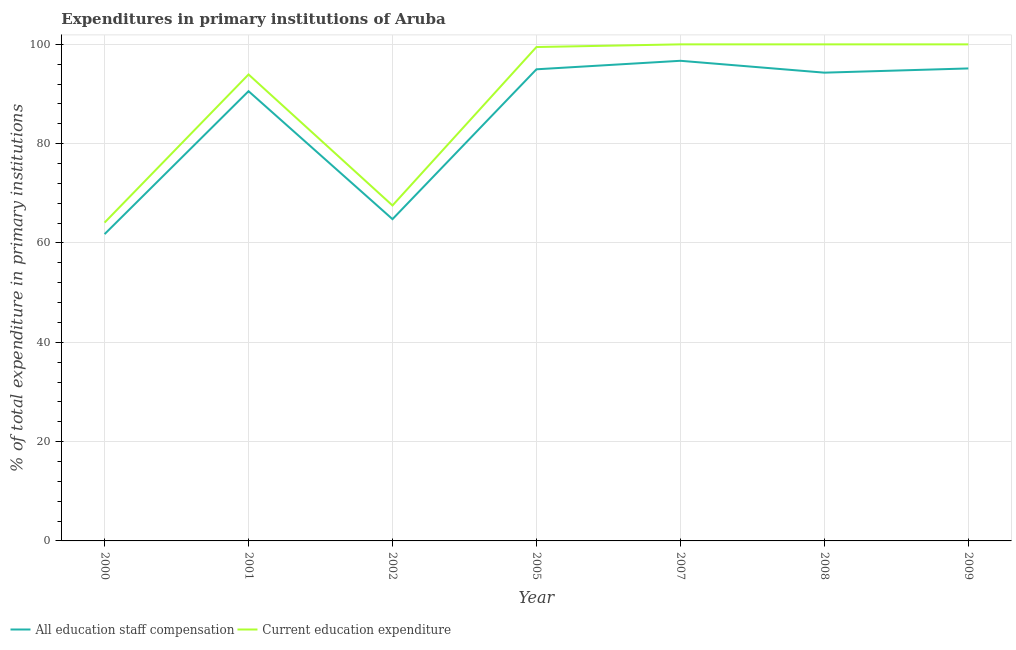How many different coloured lines are there?
Ensure brevity in your answer.  2. Does the line corresponding to expenditure in staff compensation intersect with the line corresponding to expenditure in education?
Your response must be concise. No. Is the number of lines equal to the number of legend labels?
Your response must be concise. Yes. What is the expenditure in education in 2009?
Offer a very short reply. 100. Across all years, what is the maximum expenditure in staff compensation?
Provide a succinct answer. 96.69. Across all years, what is the minimum expenditure in education?
Your answer should be very brief. 64.11. In which year was the expenditure in staff compensation maximum?
Your response must be concise. 2007. In which year was the expenditure in staff compensation minimum?
Give a very brief answer. 2000. What is the total expenditure in staff compensation in the graph?
Provide a short and direct response. 598.28. What is the difference between the expenditure in education in 2001 and that in 2005?
Your answer should be very brief. -5.52. What is the difference between the expenditure in education in 2002 and the expenditure in staff compensation in 2009?
Make the answer very short. -27.6. What is the average expenditure in education per year?
Ensure brevity in your answer.  89.29. In the year 2005, what is the difference between the expenditure in staff compensation and expenditure in education?
Give a very brief answer. -4.48. What is the ratio of the expenditure in education in 2000 to that in 2009?
Offer a very short reply. 0.64. Is the difference between the expenditure in education in 2007 and 2008 greater than the difference between the expenditure in staff compensation in 2007 and 2008?
Offer a very short reply. No. What is the difference between the highest and the lowest expenditure in education?
Offer a terse response. 35.89. In how many years, is the expenditure in staff compensation greater than the average expenditure in staff compensation taken over all years?
Offer a very short reply. 5. Is the expenditure in staff compensation strictly greater than the expenditure in education over the years?
Offer a terse response. No. Is the expenditure in education strictly less than the expenditure in staff compensation over the years?
Offer a very short reply. No. Are the values on the major ticks of Y-axis written in scientific E-notation?
Offer a terse response. No. Does the graph contain any zero values?
Offer a very short reply. No. Does the graph contain grids?
Provide a short and direct response. Yes. How are the legend labels stacked?
Your response must be concise. Horizontal. What is the title of the graph?
Your response must be concise. Expenditures in primary institutions of Aruba. What is the label or title of the Y-axis?
Your response must be concise. % of total expenditure in primary institutions. What is the % of total expenditure in primary institutions in All education staff compensation in 2000?
Keep it short and to the point. 61.78. What is the % of total expenditure in primary institutions of Current education expenditure in 2000?
Provide a short and direct response. 64.11. What is the % of total expenditure in primary institutions in All education staff compensation in 2001?
Your answer should be very brief. 90.57. What is the % of total expenditure in primary institutions in Current education expenditure in 2001?
Offer a very short reply. 93.94. What is the % of total expenditure in primary institutions in All education staff compensation in 2002?
Provide a short and direct response. 64.8. What is the % of total expenditure in primary institutions in Current education expenditure in 2002?
Your answer should be compact. 67.55. What is the % of total expenditure in primary institutions in All education staff compensation in 2005?
Make the answer very short. 94.98. What is the % of total expenditure in primary institutions of Current education expenditure in 2005?
Ensure brevity in your answer.  99.46. What is the % of total expenditure in primary institutions in All education staff compensation in 2007?
Your answer should be very brief. 96.69. What is the % of total expenditure in primary institutions in Current education expenditure in 2007?
Provide a short and direct response. 100. What is the % of total expenditure in primary institutions in All education staff compensation in 2008?
Keep it short and to the point. 94.3. What is the % of total expenditure in primary institutions of Current education expenditure in 2008?
Ensure brevity in your answer.  100. What is the % of total expenditure in primary institutions of All education staff compensation in 2009?
Your response must be concise. 95.15. What is the % of total expenditure in primary institutions of Current education expenditure in 2009?
Give a very brief answer. 100. Across all years, what is the maximum % of total expenditure in primary institutions of All education staff compensation?
Ensure brevity in your answer.  96.69. Across all years, what is the maximum % of total expenditure in primary institutions in Current education expenditure?
Make the answer very short. 100. Across all years, what is the minimum % of total expenditure in primary institutions in All education staff compensation?
Provide a short and direct response. 61.78. Across all years, what is the minimum % of total expenditure in primary institutions in Current education expenditure?
Ensure brevity in your answer.  64.11. What is the total % of total expenditure in primary institutions in All education staff compensation in the graph?
Provide a succinct answer. 598.28. What is the total % of total expenditure in primary institutions of Current education expenditure in the graph?
Give a very brief answer. 625.06. What is the difference between the % of total expenditure in primary institutions in All education staff compensation in 2000 and that in 2001?
Offer a very short reply. -28.79. What is the difference between the % of total expenditure in primary institutions in Current education expenditure in 2000 and that in 2001?
Ensure brevity in your answer.  -29.83. What is the difference between the % of total expenditure in primary institutions in All education staff compensation in 2000 and that in 2002?
Your response must be concise. -3.02. What is the difference between the % of total expenditure in primary institutions of Current education expenditure in 2000 and that in 2002?
Your answer should be compact. -3.44. What is the difference between the % of total expenditure in primary institutions of All education staff compensation in 2000 and that in 2005?
Your answer should be compact. -33.2. What is the difference between the % of total expenditure in primary institutions of Current education expenditure in 2000 and that in 2005?
Provide a succinct answer. -35.35. What is the difference between the % of total expenditure in primary institutions of All education staff compensation in 2000 and that in 2007?
Your response must be concise. -34.91. What is the difference between the % of total expenditure in primary institutions of Current education expenditure in 2000 and that in 2007?
Provide a succinct answer. -35.89. What is the difference between the % of total expenditure in primary institutions of All education staff compensation in 2000 and that in 2008?
Offer a very short reply. -32.52. What is the difference between the % of total expenditure in primary institutions in Current education expenditure in 2000 and that in 2008?
Give a very brief answer. -35.89. What is the difference between the % of total expenditure in primary institutions of All education staff compensation in 2000 and that in 2009?
Offer a terse response. -33.37. What is the difference between the % of total expenditure in primary institutions of Current education expenditure in 2000 and that in 2009?
Provide a succinct answer. -35.89. What is the difference between the % of total expenditure in primary institutions of All education staff compensation in 2001 and that in 2002?
Your answer should be very brief. 25.77. What is the difference between the % of total expenditure in primary institutions of Current education expenditure in 2001 and that in 2002?
Offer a very short reply. 26.38. What is the difference between the % of total expenditure in primary institutions in All education staff compensation in 2001 and that in 2005?
Offer a very short reply. -4.41. What is the difference between the % of total expenditure in primary institutions of Current education expenditure in 2001 and that in 2005?
Ensure brevity in your answer.  -5.52. What is the difference between the % of total expenditure in primary institutions in All education staff compensation in 2001 and that in 2007?
Offer a very short reply. -6.12. What is the difference between the % of total expenditure in primary institutions of Current education expenditure in 2001 and that in 2007?
Ensure brevity in your answer.  -6.06. What is the difference between the % of total expenditure in primary institutions of All education staff compensation in 2001 and that in 2008?
Provide a succinct answer. -3.73. What is the difference between the % of total expenditure in primary institutions in Current education expenditure in 2001 and that in 2008?
Your response must be concise. -6.06. What is the difference between the % of total expenditure in primary institutions in All education staff compensation in 2001 and that in 2009?
Your answer should be very brief. -4.58. What is the difference between the % of total expenditure in primary institutions of Current education expenditure in 2001 and that in 2009?
Make the answer very short. -6.06. What is the difference between the % of total expenditure in primary institutions of All education staff compensation in 2002 and that in 2005?
Make the answer very short. -30.18. What is the difference between the % of total expenditure in primary institutions in Current education expenditure in 2002 and that in 2005?
Keep it short and to the point. -31.91. What is the difference between the % of total expenditure in primary institutions of All education staff compensation in 2002 and that in 2007?
Make the answer very short. -31.89. What is the difference between the % of total expenditure in primary institutions of Current education expenditure in 2002 and that in 2007?
Your answer should be compact. -32.45. What is the difference between the % of total expenditure in primary institutions in All education staff compensation in 2002 and that in 2008?
Keep it short and to the point. -29.5. What is the difference between the % of total expenditure in primary institutions of Current education expenditure in 2002 and that in 2008?
Your answer should be compact. -32.45. What is the difference between the % of total expenditure in primary institutions of All education staff compensation in 2002 and that in 2009?
Give a very brief answer. -30.35. What is the difference between the % of total expenditure in primary institutions in Current education expenditure in 2002 and that in 2009?
Your answer should be compact. -32.45. What is the difference between the % of total expenditure in primary institutions of All education staff compensation in 2005 and that in 2007?
Keep it short and to the point. -1.71. What is the difference between the % of total expenditure in primary institutions in Current education expenditure in 2005 and that in 2007?
Ensure brevity in your answer.  -0.54. What is the difference between the % of total expenditure in primary institutions in All education staff compensation in 2005 and that in 2008?
Keep it short and to the point. 0.68. What is the difference between the % of total expenditure in primary institutions in Current education expenditure in 2005 and that in 2008?
Your response must be concise. -0.54. What is the difference between the % of total expenditure in primary institutions in All education staff compensation in 2005 and that in 2009?
Offer a terse response. -0.17. What is the difference between the % of total expenditure in primary institutions in Current education expenditure in 2005 and that in 2009?
Ensure brevity in your answer.  -0.54. What is the difference between the % of total expenditure in primary institutions in All education staff compensation in 2007 and that in 2008?
Your answer should be compact. 2.39. What is the difference between the % of total expenditure in primary institutions of All education staff compensation in 2007 and that in 2009?
Keep it short and to the point. 1.54. What is the difference between the % of total expenditure in primary institutions of Current education expenditure in 2007 and that in 2009?
Your answer should be very brief. 0. What is the difference between the % of total expenditure in primary institutions of All education staff compensation in 2008 and that in 2009?
Make the answer very short. -0.85. What is the difference between the % of total expenditure in primary institutions in Current education expenditure in 2008 and that in 2009?
Ensure brevity in your answer.  0. What is the difference between the % of total expenditure in primary institutions in All education staff compensation in 2000 and the % of total expenditure in primary institutions in Current education expenditure in 2001?
Provide a succinct answer. -32.15. What is the difference between the % of total expenditure in primary institutions in All education staff compensation in 2000 and the % of total expenditure in primary institutions in Current education expenditure in 2002?
Your answer should be very brief. -5.77. What is the difference between the % of total expenditure in primary institutions in All education staff compensation in 2000 and the % of total expenditure in primary institutions in Current education expenditure in 2005?
Ensure brevity in your answer.  -37.68. What is the difference between the % of total expenditure in primary institutions in All education staff compensation in 2000 and the % of total expenditure in primary institutions in Current education expenditure in 2007?
Offer a very short reply. -38.22. What is the difference between the % of total expenditure in primary institutions of All education staff compensation in 2000 and the % of total expenditure in primary institutions of Current education expenditure in 2008?
Your answer should be very brief. -38.22. What is the difference between the % of total expenditure in primary institutions of All education staff compensation in 2000 and the % of total expenditure in primary institutions of Current education expenditure in 2009?
Provide a short and direct response. -38.22. What is the difference between the % of total expenditure in primary institutions in All education staff compensation in 2001 and the % of total expenditure in primary institutions in Current education expenditure in 2002?
Your answer should be compact. 23.02. What is the difference between the % of total expenditure in primary institutions of All education staff compensation in 2001 and the % of total expenditure in primary institutions of Current education expenditure in 2005?
Make the answer very short. -8.89. What is the difference between the % of total expenditure in primary institutions in All education staff compensation in 2001 and the % of total expenditure in primary institutions in Current education expenditure in 2007?
Make the answer very short. -9.43. What is the difference between the % of total expenditure in primary institutions in All education staff compensation in 2001 and the % of total expenditure in primary institutions in Current education expenditure in 2008?
Your response must be concise. -9.43. What is the difference between the % of total expenditure in primary institutions of All education staff compensation in 2001 and the % of total expenditure in primary institutions of Current education expenditure in 2009?
Make the answer very short. -9.43. What is the difference between the % of total expenditure in primary institutions of All education staff compensation in 2002 and the % of total expenditure in primary institutions of Current education expenditure in 2005?
Provide a succinct answer. -34.66. What is the difference between the % of total expenditure in primary institutions of All education staff compensation in 2002 and the % of total expenditure in primary institutions of Current education expenditure in 2007?
Offer a very short reply. -35.2. What is the difference between the % of total expenditure in primary institutions in All education staff compensation in 2002 and the % of total expenditure in primary institutions in Current education expenditure in 2008?
Offer a very short reply. -35.2. What is the difference between the % of total expenditure in primary institutions of All education staff compensation in 2002 and the % of total expenditure in primary institutions of Current education expenditure in 2009?
Provide a short and direct response. -35.2. What is the difference between the % of total expenditure in primary institutions in All education staff compensation in 2005 and the % of total expenditure in primary institutions in Current education expenditure in 2007?
Your response must be concise. -5.02. What is the difference between the % of total expenditure in primary institutions of All education staff compensation in 2005 and the % of total expenditure in primary institutions of Current education expenditure in 2008?
Your answer should be very brief. -5.02. What is the difference between the % of total expenditure in primary institutions of All education staff compensation in 2005 and the % of total expenditure in primary institutions of Current education expenditure in 2009?
Your answer should be compact. -5.02. What is the difference between the % of total expenditure in primary institutions in All education staff compensation in 2007 and the % of total expenditure in primary institutions in Current education expenditure in 2008?
Ensure brevity in your answer.  -3.31. What is the difference between the % of total expenditure in primary institutions of All education staff compensation in 2007 and the % of total expenditure in primary institutions of Current education expenditure in 2009?
Your response must be concise. -3.31. What is the difference between the % of total expenditure in primary institutions of All education staff compensation in 2008 and the % of total expenditure in primary institutions of Current education expenditure in 2009?
Offer a terse response. -5.7. What is the average % of total expenditure in primary institutions in All education staff compensation per year?
Your answer should be very brief. 85.47. What is the average % of total expenditure in primary institutions in Current education expenditure per year?
Your answer should be compact. 89.29. In the year 2000, what is the difference between the % of total expenditure in primary institutions in All education staff compensation and % of total expenditure in primary institutions in Current education expenditure?
Offer a terse response. -2.33. In the year 2001, what is the difference between the % of total expenditure in primary institutions in All education staff compensation and % of total expenditure in primary institutions in Current education expenditure?
Your answer should be compact. -3.37. In the year 2002, what is the difference between the % of total expenditure in primary institutions of All education staff compensation and % of total expenditure in primary institutions of Current education expenditure?
Your answer should be very brief. -2.75. In the year 2005, what is the difference between the % of total expenditure in primary institutions of All education staff compensation and % of total expenditure in primary institutions of Current education expenditure?
Your answer should be very brief. -4.48. In the year 2007, what is the difference between the % of total expenditure in primary institutions of All education staff compensation and % of total expenditure in primary institutions of Current education expenditure?
Ensure brevity in your answer.  -3.31. In the year 2008, what is the difference between the % of total expenditure in primary institutions in All education staff compensation and % of total expenditure in primary institutions in Current education expenditure?
Keep it short and to the point. -5.7. In the year 2009, what is the difference between the % of total expenditure in primary institutions in All education staff compensation and % of total expenditure in primary institutions in Current education expenditure?
Your answer should be very brief. -4.85. What is the ratio of the % of total expenditure in primary institutions of All education staff compensation in 2000 to that in 2001?
Give a very brief answer. 0.68. What is the ratio of the % of total expenditure in primary institutions of Current education expenditure in 2000 to that in 2001?
Offer a terse response. 0.68. What is the ratio of the % of total expenditure in primary institutions in All education staff compensation in 2000 to that in 2002?
Your answer should be very brief. 0.95. What is the ratio of the % of total expenditure in primary institutions of Current education expenditure in 2000 to that in 2002?
Your response must be concise. 0.95. What is the ratio of the % of total expenditure in primary institutions of All education staff compensation in 2000 to that in 2005?
Make the answer very short. 0.65. What is the ratio of the % of total expenditure in primary institutions in Current education expenditure in 2000 to that in 2005?
Offer a terse response. 0.64. What is the ratio of the % of total expenditure in primary institutions in All education staff compensation in 2000 to that in 2007?
Offer a very short reply. 0.64. What is the ratio of the % of total expenditure in primary institutions of Current education expenditure in 2000 to that in 2007?
Provide a succinct answer. 0.64. What is the ratio of the % of total expenditure in primary institutions in All education staff compensation in 2000 to that in 2008?
Give a very brief answer. 0.66. What is the ratio of the % of total expenditure in primary institutions of Current education expenditure in 2000 to that in 2008?
Ensure brevity in your answer.  0.64. What is the ratio of the % of total expenditure in primary institutions in All education staff compensation in 2000 to that in 2009?
Offer a very short reply. 0.65. What is the ratio of the % of total expenditure in primary institutions in Current education expenditure in 2000 to that in 2009?
Ensure brevity in your answer.  0.64. What is the ratio of the % of total expenditure in primary institutions in All education staff compensation in 2001 to that in 2002?
Ensure brevity in your answer.  1.4. What is the ratio of the % of total expenditure in primary institutions in Current education expenditure in 2001 to that in 2002?
Keep it short and to the point. 1.39. What is the ratio of the % of total expenditure in primary institutions of All education staff compensation in 2001 to that in 2005?
Give a very brief answer. 0.95. What is the ratio of the % of total expenditure in primary institutions in Current education expenditure in 2001 to that in 2005?
Your answer should be very brief. 0.94. What is the ratio of the % of total expenditure in primary institutions in All education staff compensation in 2001 to that in 2007?
Provide a short and direct response. 0.94. What is the ratio of the % of total expenditure in primary institutions in Current education expenditure in 2001 to that in 2007?
Ensure brevity in your answer.  0.94. What is the ratio of the % of total expenditure in primary institutions of All education staff compensation in 2001 to that in 2008?
Your response must be concise. 0.96. What is the ratio of the % of total expenditure in primary institutions in Current education expenditure in 2001 to that in 2008?
Make the answer very short. 0.94. What is the ratio of the % of total expenditure in primary institutions of All education staff compensation in 2001 to that in 2009?
Make the answer very short. 0.95. What is the ratio of the % of total expenditure in primary institutions in Current education expenditure in 2001 to that in 2009?
Make the answer very short. 0.94. What is the ratio of the % of total expenditure in primary institutions in All education staff compensation in 2002 to that in 2005?
Ensure brevity in your answer.  0.68. What is the ratio of the % of total expenditure in primary institutions in Current education expenditure in 2002 to that in 2005?
Give a very brief answer. 0.68. What is the ratio of the % of total expenditure in primary institutions in All education staff compensation in 2002 to that in 2007?
Your response must be concise. 0.67. What is the ratio of the % of total expenditure in primary institutions in Current education expenditure in 2002 to that in 2007?
Keep it short and to the point. 0.68. What is the ratio of the % of total expenditure in primary institutions in All education staff compensation in 2002 to that in 2008?
Offer a terse response. 0.69. What is the ratio of the % of total expenditure in primary institutions in Current education expenditure in 2002 to that in 2008?
Your answer should be compact. 0.68. What is the ratio of the % of total expenditure in primary institutions in All education staff compensation in 2002 to that in 2009?
Keep it short and to the point. 0.68. What is the ratio of the % of total expenditure in primary institutions in Current education expenditure in 2002 to that in 2009?
Give a very brief answer. 0.68. What is the ratio of the % of total expenditure in primary institutions of All education staff compensation in 2005 to that in 2007?
Offer a terse response. 0.98. What is the ratio of the % of total expenditure in primary institutions of All education staff compensation in 2005 to that in 2008?
Your response must be concise. 1.01. What is the ratio of the % of total expenditure in primary institutions of Current education expenditure in 2005 to that in 2009?
Give a very brief answer. 0.99. What is the ratio of the % of total expenditure in primary institutions of All education staff compensation in 2007 to that in 2008?
Ensure brevity in your answer.  1.03. What is the ratio of the % of total expenditure in primary institutions in Current education expenditure in 2007 to that in 2008?
Ensure brevity in your answer.  1. What is the ratio of the % of total expenditure in primary institutions of All education staff compensation in 2007 to that in 2009?
Offer a terse response. 1.02. What is the ratio of the % of total expenditure in primary institutions in Current education expenditure in 2007 to that in 2009?
Make the answer very short. 1. What is the ratio of the % of total expenditure in primary institutions of All education staff compensation in 2008 to that in 2009?
Provide a succinct answer. 0.99. What is the difference between the highest and the second highest % of total expenditure in primary institutions of All education staff compensation?
Make the answer very short. 1.54. What is the difference between the highest and the second highest % of total expenditure in primary institutions of Current education expenditure?
Ensure brevity in your answer.  0. What is the difference between the highest and the lowest % of total expenditure in primary institutions of All education staff compensation?
Your response must be concise. 34.91. What is the difference between the highest and the lowest % of total expenditure in primary institutions of Current education expenditure?
Ensure brevity in your answer.  35.89. 